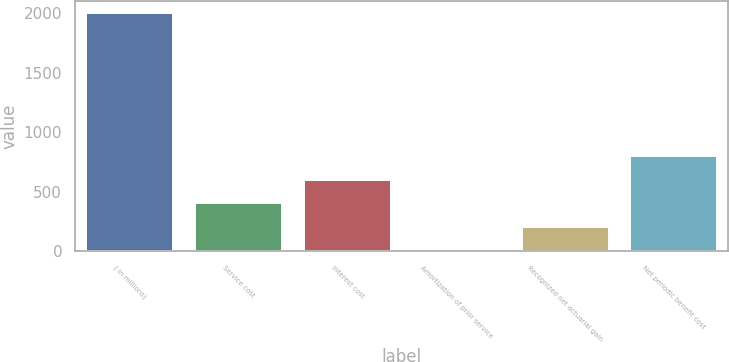<chart> <loc_0><loc_0><loc_500><loc_500><bar_chart><fcel>( in millions)<fcel>Service cost<fcel>Interest cost<fcel>Amortization of prior service<fcel>Recognized net actuarial gain<fcel>Net periodic benefit cost<nl><fcel>2007<fcel>401.72<fcel>602.38<fcel>0.4<fcel>201.06<fcel>803.04<nl></chart> 